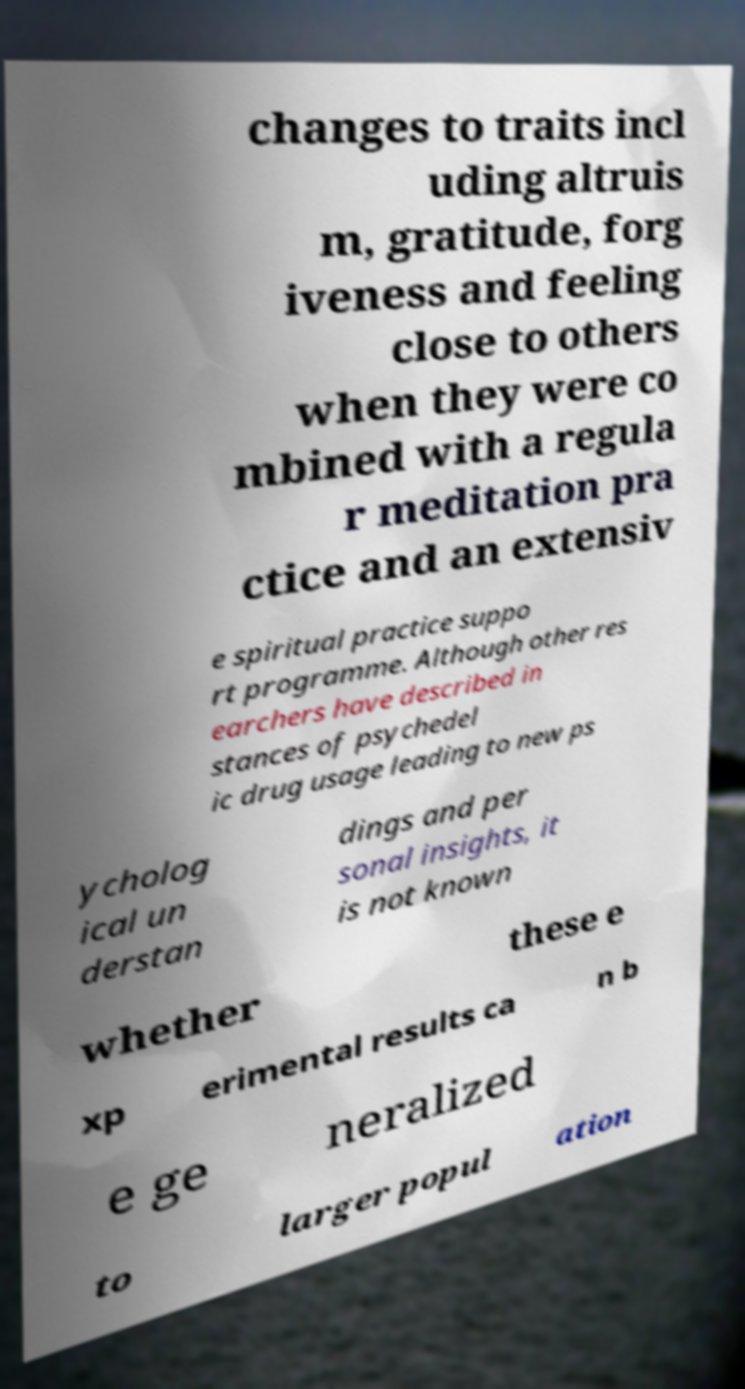Please identify and transcribe the text found in this image. changes to traits incl uding altruis m, gratitude, forg iveness and feeling close to others when they were co mbined with a regula r meditation pra ctice and an extensiv e spiritual practice suppo rt programme. Although other res earchers have described in stances of psychedel ic drug usage leading to new ps ycholog ical un derstan dings and per sonal insights, it is not known whether these e xp erimental results ca n b e ge neralized to larger popul ation 